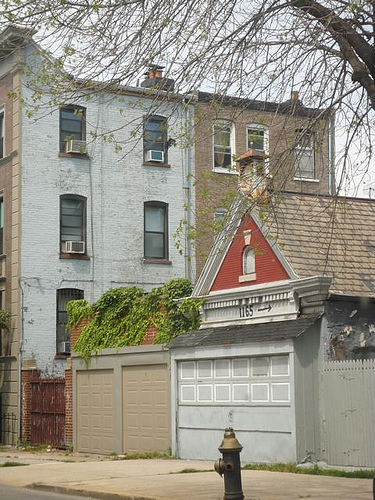<image>Who is the street? It is unknown who is on the street. There might be no one. Who is the street? I don't know who the street is. It can be seen as 'nobody', 'no one' or 'unknown'. 